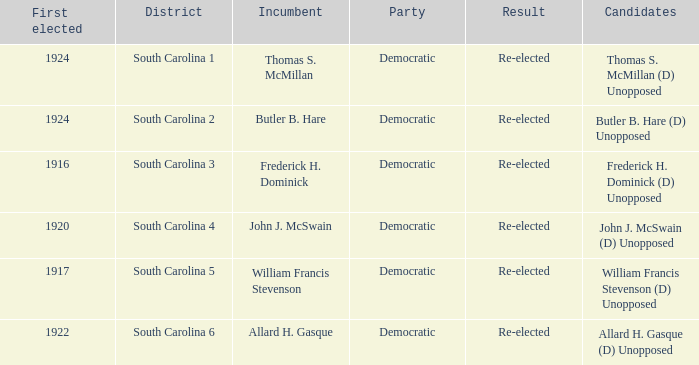Name the candidate for south carolina 1? Thomas S. McMillan (D) Unopposed. 